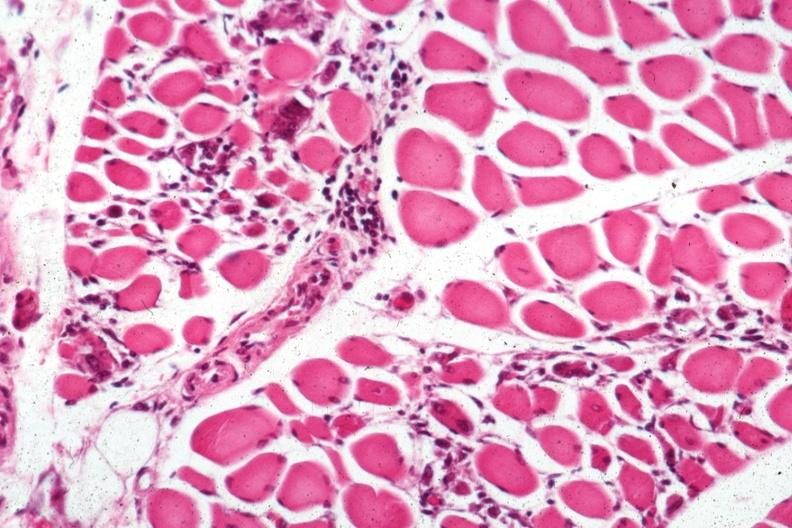what does this image show?
Answer the question using a single word or phrase. Small lymphorrhages 